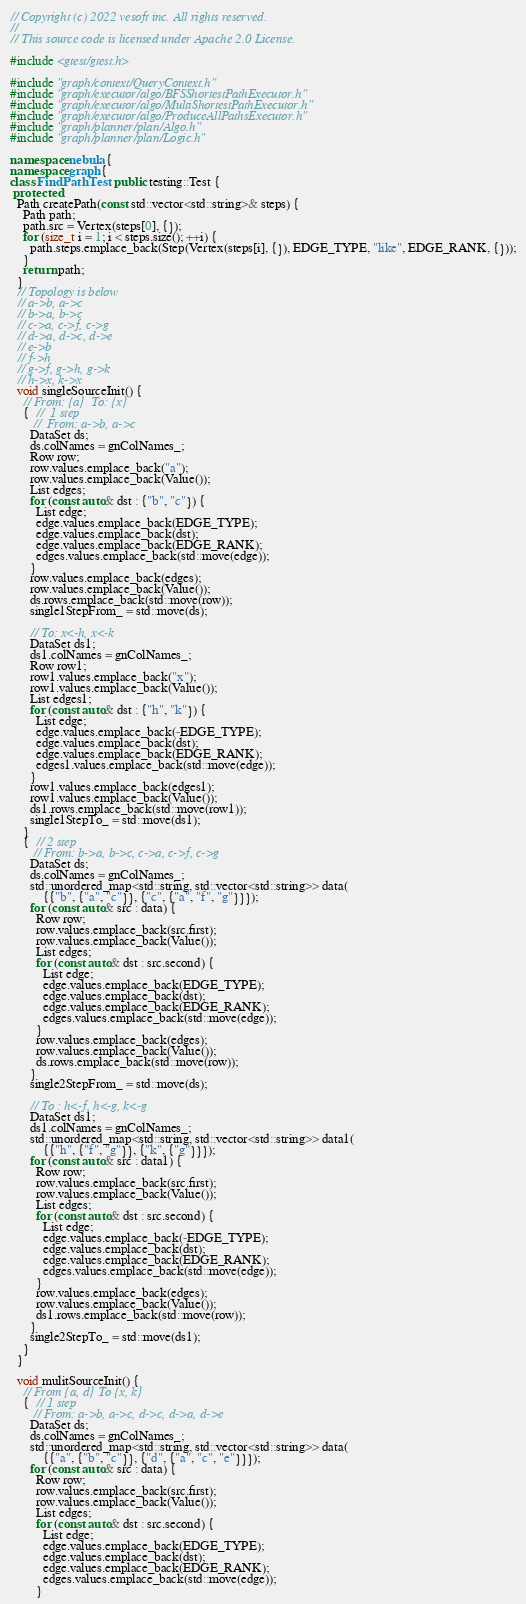<code> <loc_0><loc_0><loc_500><loc_500><_C++_>// Copyright (c) 2022 vesoft inc. All rights reserved.
//
// This source code is licensed under Apache 2.0 License.

#include <gtest/gtest.h>

#include "graph/context/QueryContext.h"
#include "graph/executor/algo/BFSShortestPathExecutor.h"
#include "graph/executor/algo/MultiShortestPathExecutor.h"
#include "graph/executor/algo/ProduceAllPathsExecutor.h"
#include "graph/planner/plan/Algo.h"
#include "graph/planner/plan/Logic.h"

namespace nebula {
namespace graph {
class FindPathTest : public testing::Test {
 protected:
  Path createPath(const std::vector<std::string>& steps) {
    Path path;
    path.src = Vertex(steps[0], {});
    for (size_t i = 1; i < steps.size(); ++i) {
      path.steps.emplace_back(Step(Vertex(steps[i], {}), EDGE_TYPE, "like", EDGE_RANK, {}));
    }
    return path;
  }
  // Topology is below
  // a->b, a->c
  // b->a, b->c
  // c->a, c->f, c->g
  // d->a, d->c, d->e
  // e->b
  // f->h
  // g->f, g->h, g->k
  // h->x, k->x
  void singleSourceInit() {
    // From: {a}  To: {x}
    {  //  1 step
       //  From: a->b, a->c
      DataSet ds;
      ds.colNames = gnColNames_;
      Row row;
      row.values.emplace_back("a");
      row.values.emplace_back(Value());
      List edges;
      for (const auto& dst : {"b", "c"}) {
        List edge;
        edge.values.emplace_back(EDGE_TYPE);
        edge.values.emplace_back(dst);
        edge.values.emplace_back(EDGE_RANK);
        edges.values.emplace_back(std::move(edge));
      }
      row.values.emplace_back(edges);
      row.values.emplace_back(Value());
      ds.rows.emplace_back(std::move(row));
      single1StepFrom_ = std::move(ds);

      // To: x<-h, x<-k
      DataSet ds1;
      ds1.colNames = gnColNames_;
      Row row1;
      row1.values.emplace_back("x");
      row1.values.emplace_back(Value());
      List edges1;
      for (const auto& dst : {"h", "k"}) {
        List edge;
        edge.values.emplace_back(-EDGE_TYPE);
        edge.values.emplace_back(dst);
        edge.values.emplace_back(EDGE_RANK);
        edges1.values.emplace_back(std::move(edge));
      }
      row1.values.emplace_back(edges1);
      row1.values.emplace_back(Value());
      ds1.rows.emplace_back(std::move(row1));
      single1StepTo_ = std::move(ds1);
    }
    {  // 2 step
       // From: b->a, b->c, c->a, c->f, c->g
      DataSet ds;
      ds.colNames = gnColNames_;
      std::unordered_map<std::string, std::vector<std::string>> data(
          {{"b", {"a", "c"}}, {"c", {"a", "f", "g"}}});
      for (const auto& src : data) {
        Row row;
        row.values.emplace_back(src.first);
        row.values.emplace_back(Value());
        List edges;
        for (const auto& dst : src.second) {
          List edge;
          edge.values.emplace_back(EDGE_TYPE);
          edge.values.emplace_back(dst);
          edge.values.emplace_back(EDGE_RANK);
          edges.values.emplace_back(std::move(edge));
        }
        row.values.emplace_back(edges);
        row.values.emplace_back(Value());
        ds.rows.emplace_back(std::move(row));
      }
      single2StepFrom_ = std::move(ds);

      // To : h<-f, h<-g, k<-g
      DataSet ds1;
      ds1.colNames = gnColNames_;
      std::unordered_map<std::string, std::vector<std::string>> data1(
          {{"h", {"f", "g"}}, {"k", {"g"}}});
      for (const auto& src : data1) {
        Row row;
        row.values.emplace_back(src.first);
        row.values.emplace_back(Value());
        List edges;
        for (const auto& dst : src.second) {
          List edge;
          edge.values.emplace_back(-EDGE_TYPE);
          edge.values.emplace_back(dst);
          edge.values.emplace_back(EDGE_RANK);
          edges.values.emplace_back(std::move(edge));
        }
        row.values.emplace_back(edges);
        row.values.emplace_back(Value());
        ds1.rows.emplace_back(std::move(row));
      }
      single2StepTo_ = std::move(ds1);
    }
  }

  void mulitSourceInit() {
    // From {a, d} To {x, k}
    {  // 1 step
       // From: a->b, a->c, d->c, d->a, d->e
      DataSet ds;
      ds.colNames = gnColNames_;
      std::unordered_map<std::string, std::vector<std::string>> data(
          {{"a", {"b", "c"}}, {"d", {"a", "c", "e"}}});
      for (const auto& src : data) {
        Row row;
        row.values.emplace_back(src.first);
        row.values.emplace_back(Value());
        List edges;
        for (const auto& dst : src.second) {
          List edge;
          edge.values.emplace_back(EDGE_TYPE);
          edge.values.emplace_back(dst);
          edge.values.emplace_back(EDGE_RANK);
          edges.values.emplace_back(std::move(edge));
        }</code> 